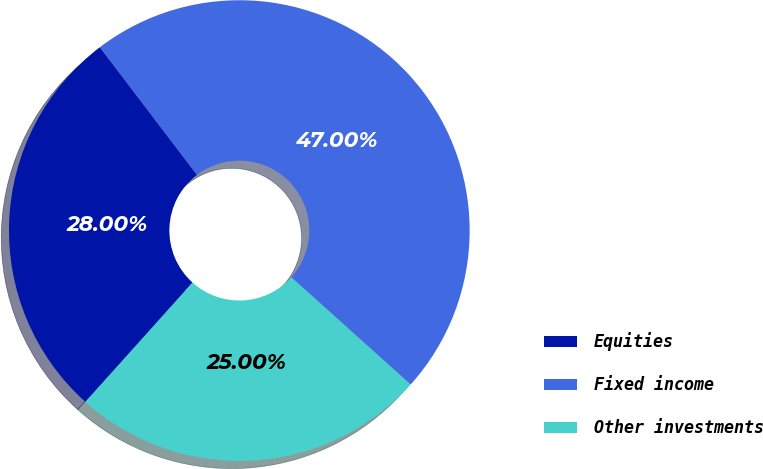<chart> <loc_0><loc_0><loc_500><loc_500><pie_chart><fcel>Equities<fcel>Fixed income<fcel>Other investments<nl><fcel>28.0%<fcel>47.0%<fcel>25.0%<nl></chart> 